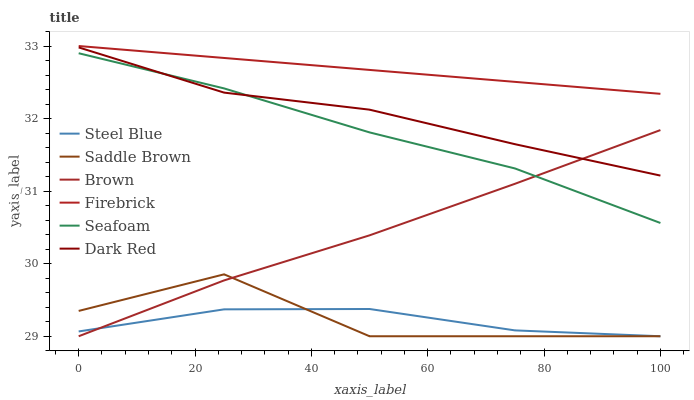Does Steel Blue have the minimum area under the curve?
Answer yes or no. Yes. Does Firebrick have the maximum area under the curve?
Answer yes or no. Yes. Does Dark Red have the minimum area under the curve?
Answer yes or no. No. Does Dark Red have the maximum area under the curve?
Answer yes or no. No. Is Firebrick the smoothest?
Answer yes or no. Yes. Is Saddle Brown the roughest?
Answer yes or no. Yes. Is Dark Red the smoothest?
Answer yes or no. No. Is Dark Red the roughest?
Answer yes or no. No. Does Dark Red have the lowest value?
Answer yes or no. No. Does Firebrick have the highest value?
Answer yes or no. Yes. Does Dark Red have the highest value?
Answer yes or no. No. Is Seafoam less than Firebrick?
Answer yes or no. Yes. Is Firebrick greater than Seafoam?
Answer yes or no. Yes. Does Saddle Brown intersect Steel Blue?
Answer yes or no. Yes. Is Saddle Brown less than Steel Blue?
Answer yes or no. No. Is Saddle Brown greater than Steel Blue?
Answer yes or no. No. Does Seafoam intersect Firebrick?
Answer yes or no. No. 